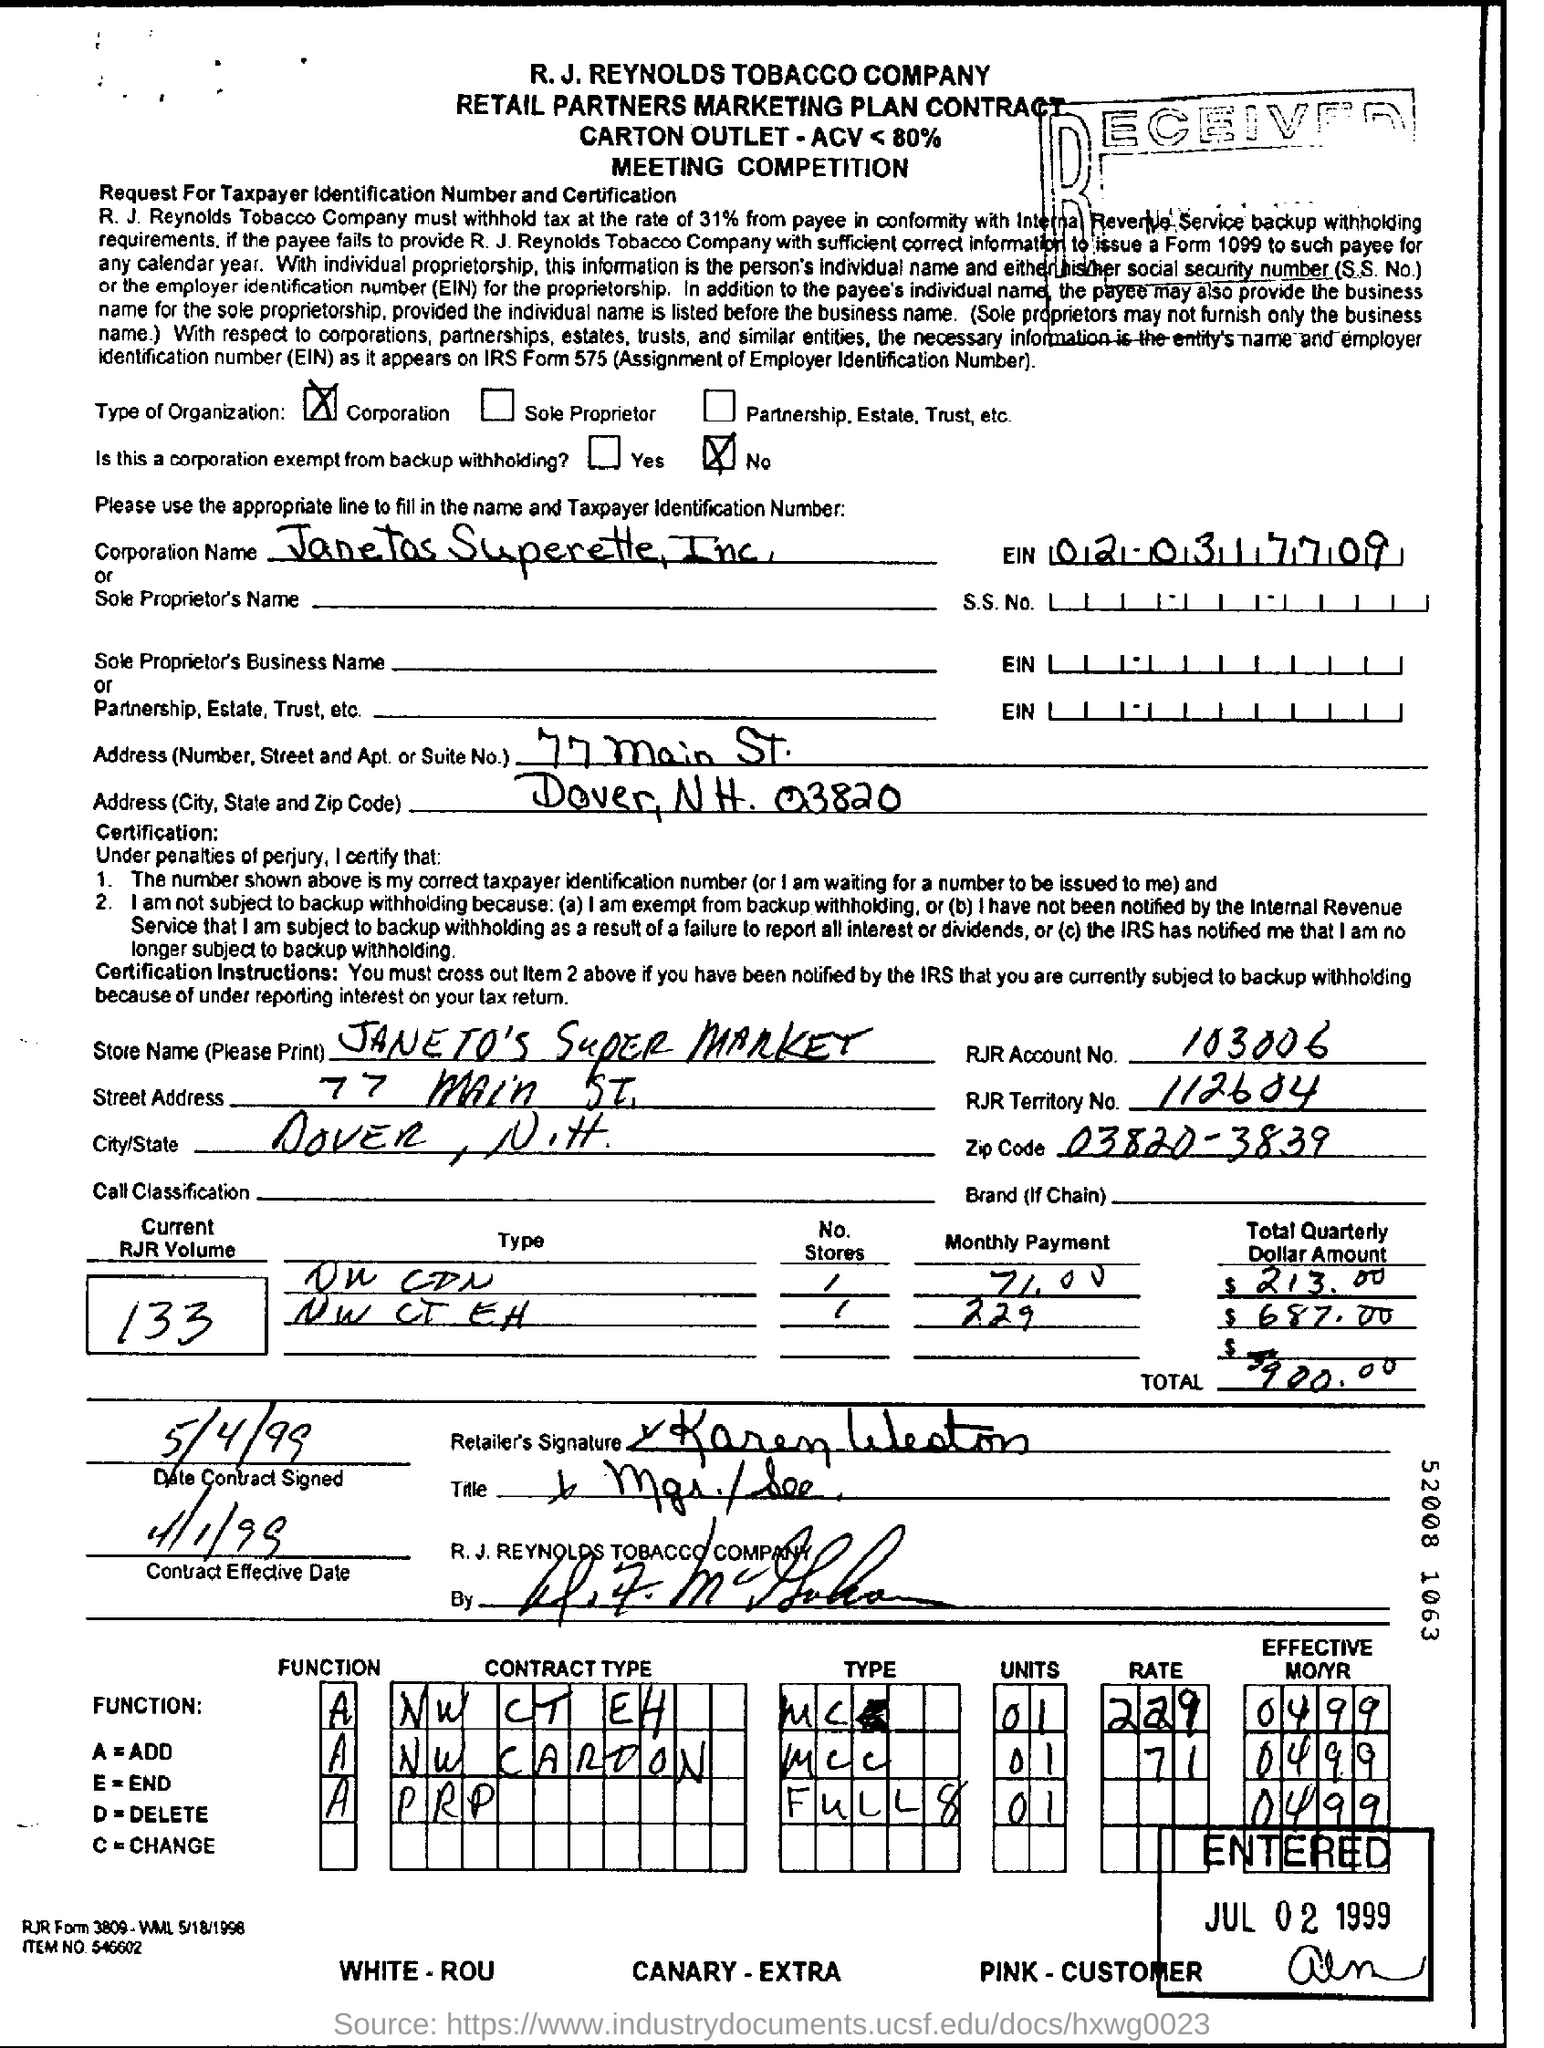Point out several critical features in this image. The zipcode mentioned in this document is 03820-3839. On May 4, 1999, the date of the contract signing was recorded. The RJR Territory identified in the document is 112604. The store name mentioned in the document is JANETO'S SUPER MARKET. The RJR account number is 103006. 